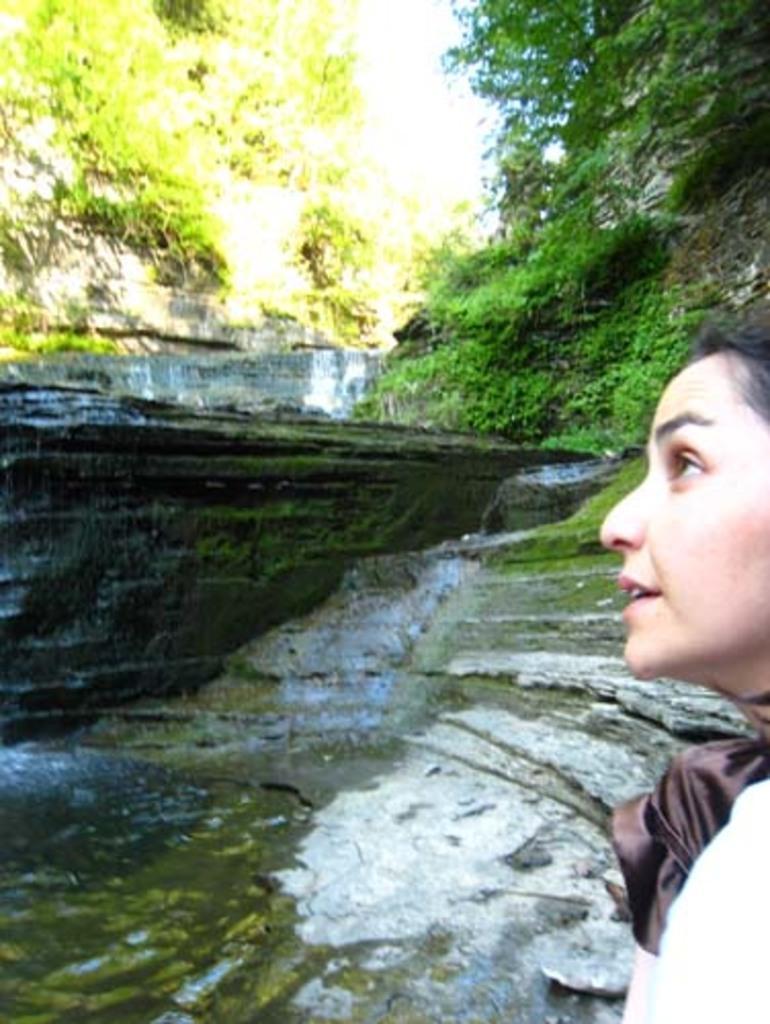Please provide a concise description of this image. In this picture I can see a woman on the right side, on the left side there is water. In the middle it looks like a rock, at the top there are trees. 